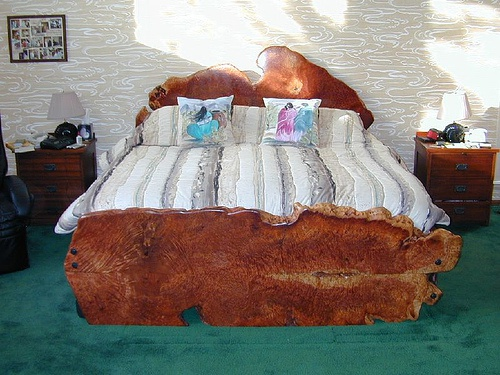Describe the objects in this image and their specific colors. I can see bed in darkgray, maroon, lightgray, and brown tones and chair in darkgray, black, navy, darkblue, and gray tones in this image. 